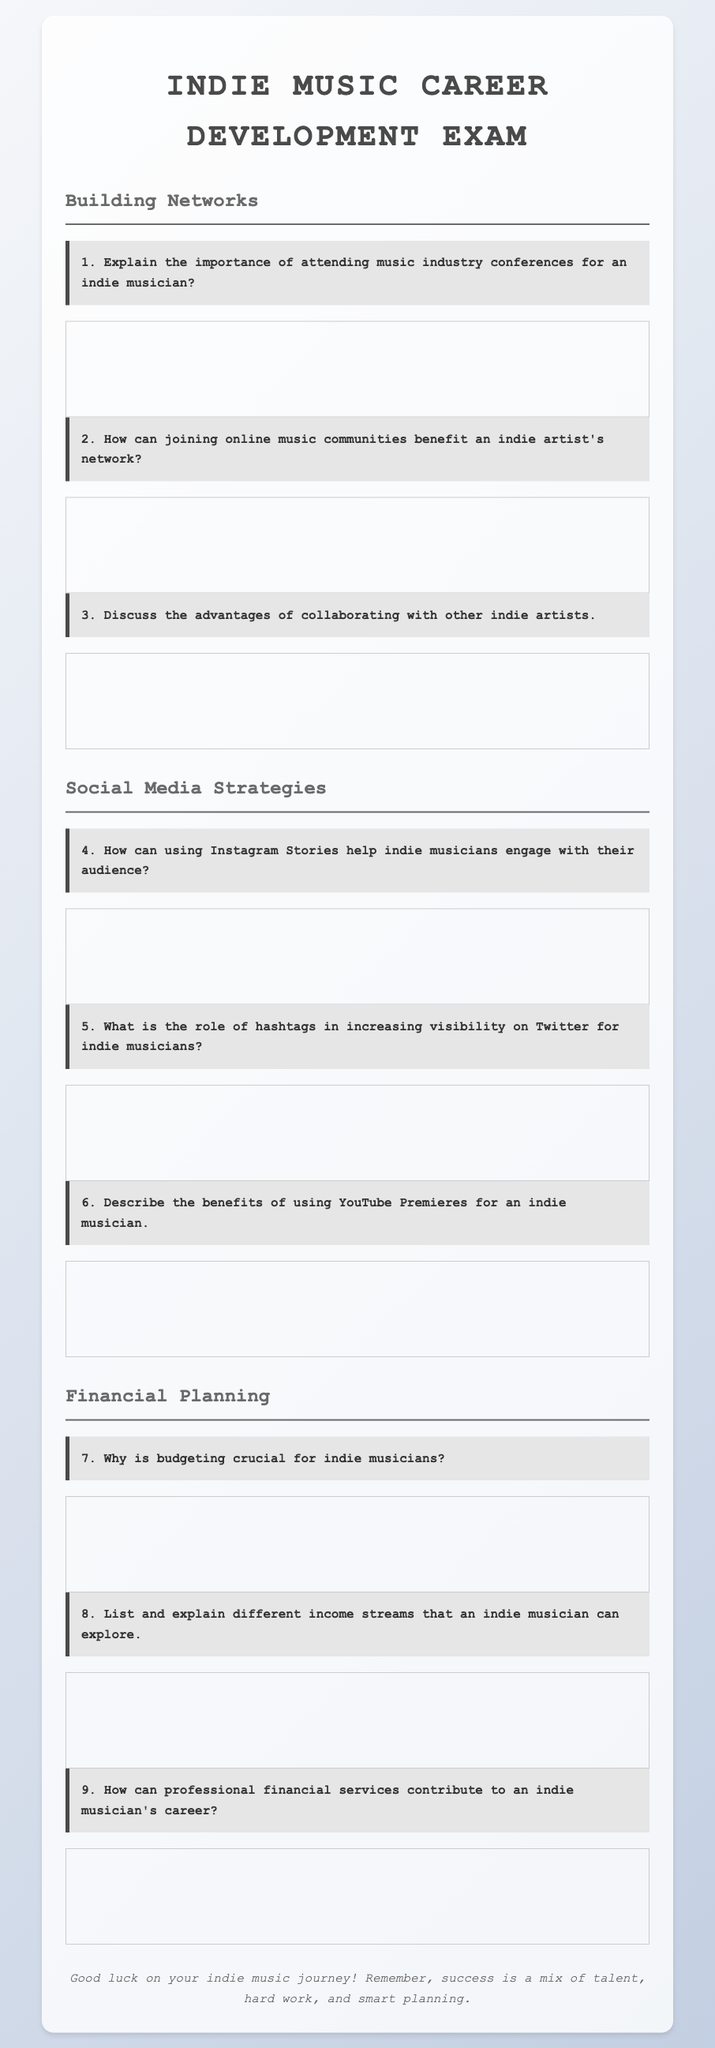What is the title of the document? The title of the document is indicated in the header section and reads "Indie Music Career Development Exam."
Answer: Indie Music Career Development Exam How many sections are in the document? The document contains three main sections: Building Networks, Social Media Strategies, and Financial Planning.
Answer: 3 What is the first question about? The first question pertains to the significance of attending music industry conferences for indie musicians.
Answer: Importance of attending music industry conferences What is the third question related to? The third question discusses the advantages of collaborating with other indie artists.
Answer: Advantages of collaborating with other indie artists What is the last question listed in the document? The last question asks how professional financial services can contribute to an indie musician's career.
Answer: How professional financial services can contribute to an indie musician's career What is mentioned about Instagram Stories? The document features a question on how using Instagram Stories engages indie musicians with their audience.
Answer: Engaging with their audience How many questions focus on Financial Planning? There are three questions dedicated to Financial Planning, concerning budgeting, income streams, and financial services.
Answer: 3 What does the footer reinforce? The footer emphasizes the blend of talent, hard work, and smart planning for success in the indie music journey.
Answer: Success is a mix of talent, hard work, and smart planning 